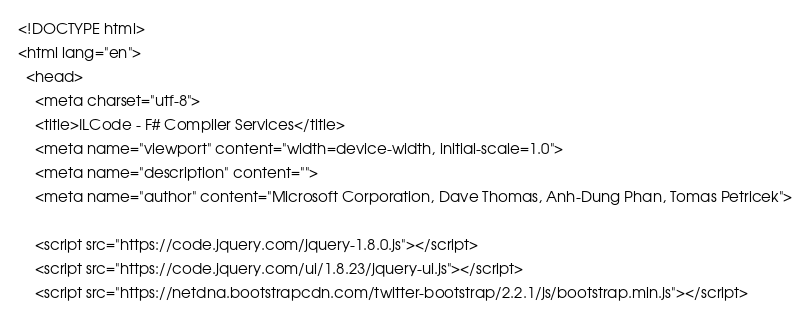<code> <loc_0><loc_0><loc_500><loc_500><_HTML_><!DOCTYPE html>
<html lang="en">
  <head>
    <meta charset="utf-8">
    <title>ILCode - F# Compiler Services</title>
    <meta name="viewport" content="width=device-width, initial-scale=1.0">
    <meta name="description" content="">
    <meta name="author" content="Microsoft Corporation, Dave Thomas, Anh-Dung Phan, Tomas Petricek">

    <script src="https://code.jquery.com/jquery-1.8.0.js"></script>
    <script src="https://code.jquery.com/ui/1.8.23/jquery-ui.js"></script>
    <script src="https://netdna.bootstrapcdn.com/twitter-bootstrap/2.2.1/js/bootstrap.min.js"></script></code> 